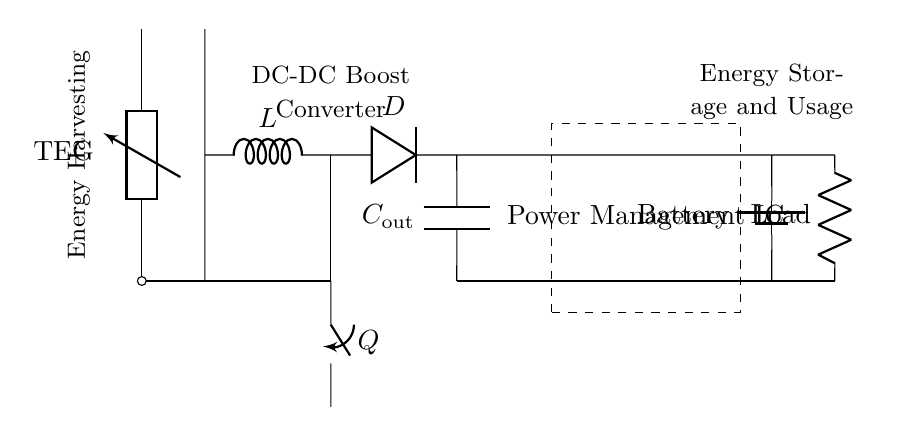What is the main component for energy harvesting? The main component is the thermoelectric generator (TEG), which is responsible for converting heat energy into electrical energy.
Answer: thermoelectric generator What does the inductor in the circuit represent? The inductor (L) in the circuit is part of the DC-DC boost converter, which helps in regulating and stepping up the voltage from the thermoelectric generator.
Answer: DC-DC boost converter What is the purpose of the diode labeled D? The diode (D) allows current to flow in one direction, preventing backflow and ensuring that the energy stored in the capacitor can be used to charge the load effectively.
Answer: one-way current flow Which component stores the energy harvested? The capacitor (C_out) stores the energy harvested from the thermoelectric generator, allowing it to be released to the load when needed.
Answer: capacitor What is the role of the Power Management IC? The Power Management IC manages the energy distribution and ensures optimal charging of the battery and usage of the power for the load, making it central to the circuit's efficiency.
Answer: energy management How is the load connected to the circuit? The load is connected in parallel with the rest of the circuit, receiving power directly from where the energy is accumulated in order to function properly.
Answer: in parallel What energy storage component is indicated in the circuit? The energy storage component indicated in the circuit is the battery, which stores electrical energy for later use by the load.
Answer: battery 